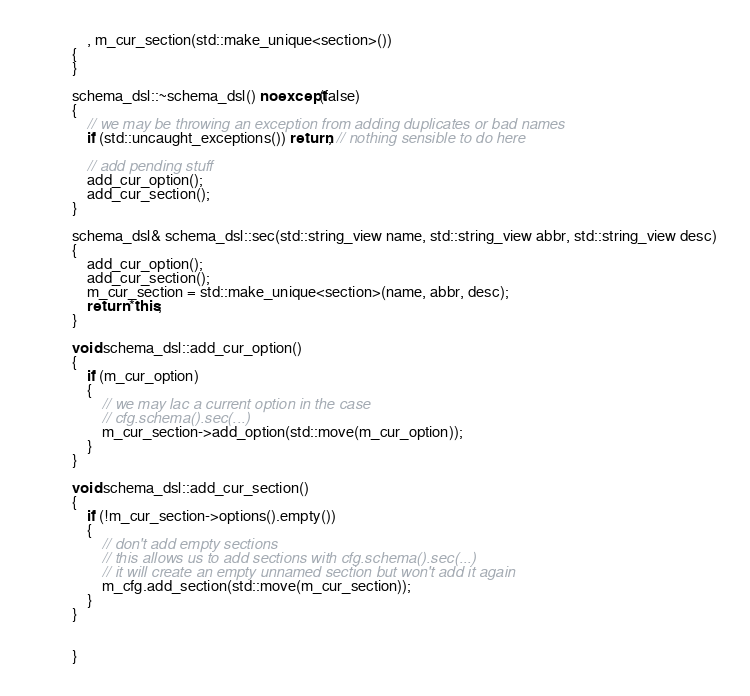Convert code to text. <code><loc_0><loc_0><loc_500><loc_500><_C++_>    , m_cur_section(std::make_unique<section>())
{
}

schema_dsl::~schema_dsl() noexcept(false)
{
    // we may be throwing an exception from adding duplicates or bad names
    if (std::uncaught_exceptions()) return; // nothing sensible to do here

    // add pending stuff
    add_cur_option();
    add_cur_section();
}

schema_dsl& schema_dsl::sec(std::string_view name, std::string_view abbr, std::string_view desc)
{
    add_cur_option();
    add_cur_section();
    m_cur_section = std::make_unique<section>(name, abbr, desc);
    return *this;
}

void schema_dsl::add_cur_option()
{
    if (m_cur_option)
    {
        // we may lac a current option in the case
        // cfg.schema().sec(...)
        m_cur_section->add_option(std::move(m_cur_option));
    }
}

void schema_dsl::add_cur_section()
{
    if (!m_cur_section->options().empty())
    {
        // don't add empty sections
        // this allows us to add sections with cfg.schema().sec(...)
        // it will create an empty unnamed section but won't add it again
        m_cfg.add_section(std::move(m_cur_section));
    }
}


}
</code> 